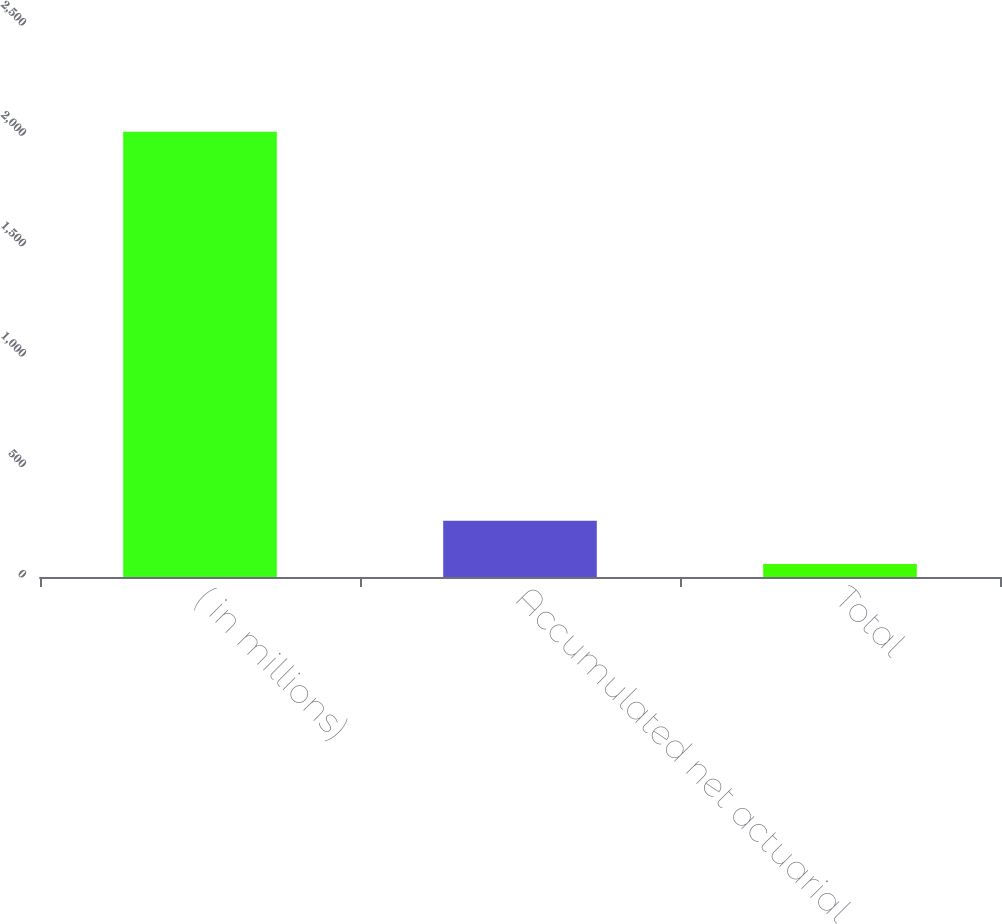<chart> <loc_0><loc_0><loc_500><loc_500><bar_chart><fcel>( in millions)<fcel>Accumulated net actuarial<fcel>Total<nl><fcel>2017<fcel>254.8<fcel>59<nl></chart> 